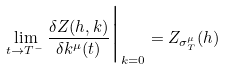Convert formula to latex. <formula><loc_0><loc_0><loc_500><loc_500>\lim _ { t \to T ^ { - } } \frac { \delta Z ( h , k ) } { \delta k ^ { \mu } ( t ) } \Big | _ { k = 0 } = Z _ { \sigma ^ { \mu } _ { T } } ( h )</formula> 